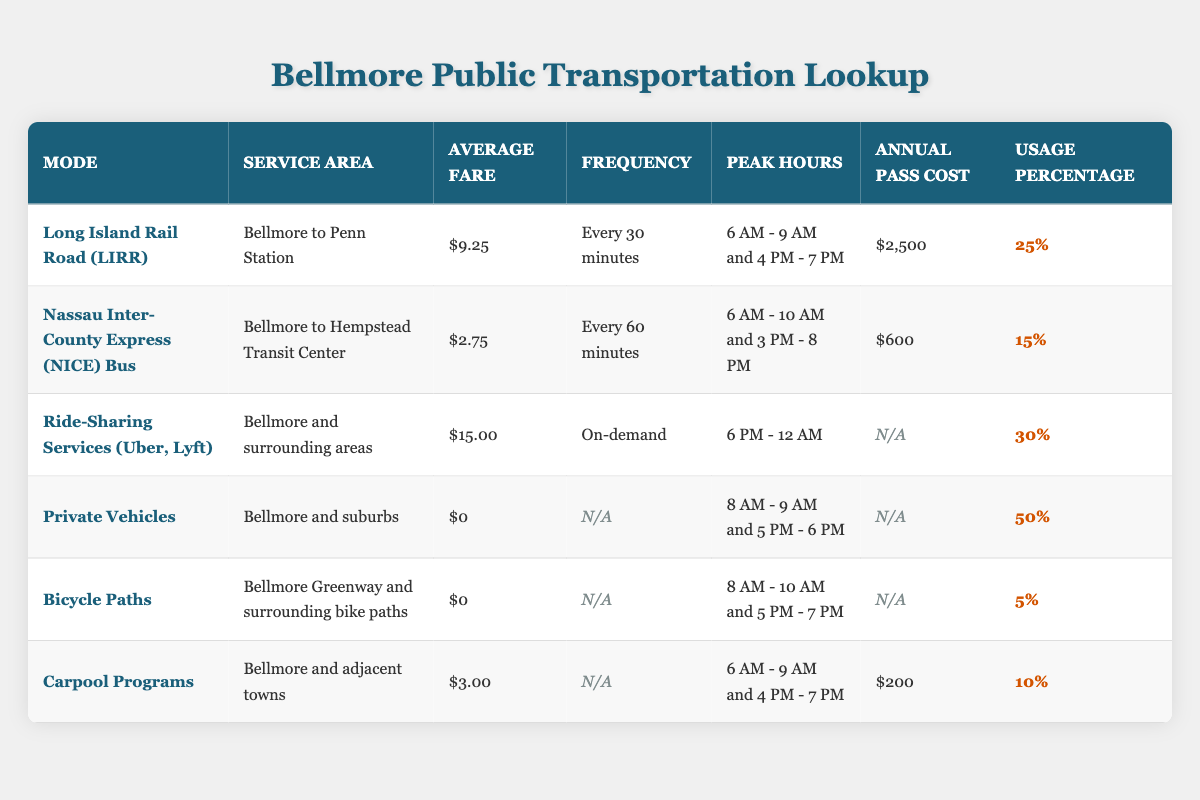What is the average fare for the Long Island Rail Road (LIRR)? The LIRR has an average fare listed in the table. Since the LIRR's average fare is $9.25, that is the answer to this question.
Answer: $9.25 Which mode of transportation has the highest usage percentage? By reviewing the usage percentages in the table, Private Vehicles have the highest usage percentage at 50%.
Answer: Private Vehicles What is the total average fare of the NICE Bus and Carpool Programs? From the table, the NICE Bus fare is $2.75 and the Carpool Program fare is $3.00. Therefore, we can sum these two: $2.75 + $3.00 = $5.75.
Answer: $5.75 Is the annual pass cost for Ride-Sharing Services available in the table? The annual pass cost for Ride-Sharing Services is marked as N/A, indicating that there is no annual pass cost available for this mode of transportation.
Answer: No What are the peak hours for the Nassau Inter-County Express (NICE) Bus? The table specifies that the peak hours for the NICE Bus are from 6 AM to 10 AM and 3 PM to 8 PM.
Answer: 6 AM - 10 AM and 3 PM - 8 PM Which transportation mode has a frequency of every 60 minutes? The NICE Bus service has a frequency of every 60 minutes, as stated in the table's frequency column.
Answer: Nassau Inter-County Express (NICE) Bus What is the difference in usage percentage between Ride-Sharing Services and Bicycle Paths? The usage percentage for Ride-Sharing Services is 30% and for Bicycle Paths, it is 5%. The difference is calculated as 30% - 5% = 25%.
Answer: 25% Are Ride-Sharing Services available for a specific service area? The table indicates that Ride-Sharing Services operate in Bellmore and surrounding areas, meaning they provide a specific service area.
Answer: Yes What mode of transportation has the lowest usage percentage? By examining the usage percentages, Bicycle Paths have the lowest percentage at 5%.
Answer: Bicycle Paths 